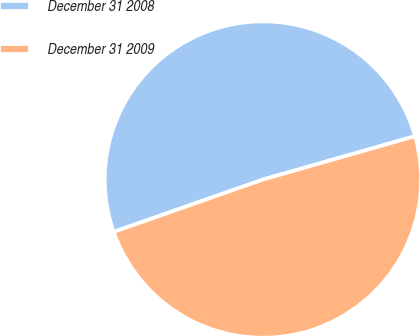Convert chart to OTSL. <chart><loc_0><loc_0><loc_500><loc_500><pie_chart><fcel>December 31 2008<fcel>December 31 2009<nl><fcel>50.94%<fcel>49.06%<nl></chart> 